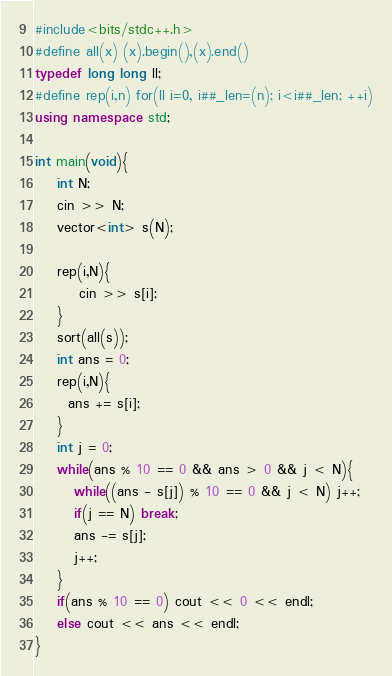<code> <loc_0><loc_0><loc_500><loc_500><_C++_>#include<bits/stdc++.h>
#define all(x) (x).begin(),(x).end()
typedef long long ll;
#define rep(i,n) for(ll i=0, i##_len=(n); i<i##_len; ++i)
using namespace std;

int main(void){
    int N;
    cin >> N;
    vector<int> s(N);
    
    rep(i,N){
        cin >> s[i];
    }
    sort(all(s));
    int ans = 0;
    rep(i,N){
      ans += s[i];
    }
    int j = 0;
    while(ans % 10 == 0 && ans > 0 && j < N){
       while((ans - s[j]) % 10 == 0 && j < N) j++;
       if(j == N) break;
       ans -= s[j];
       j++;
    }
    if(ans % 10 == 0) cout << 0 << endl;
    else cout << ans << endl;
}
</code> 